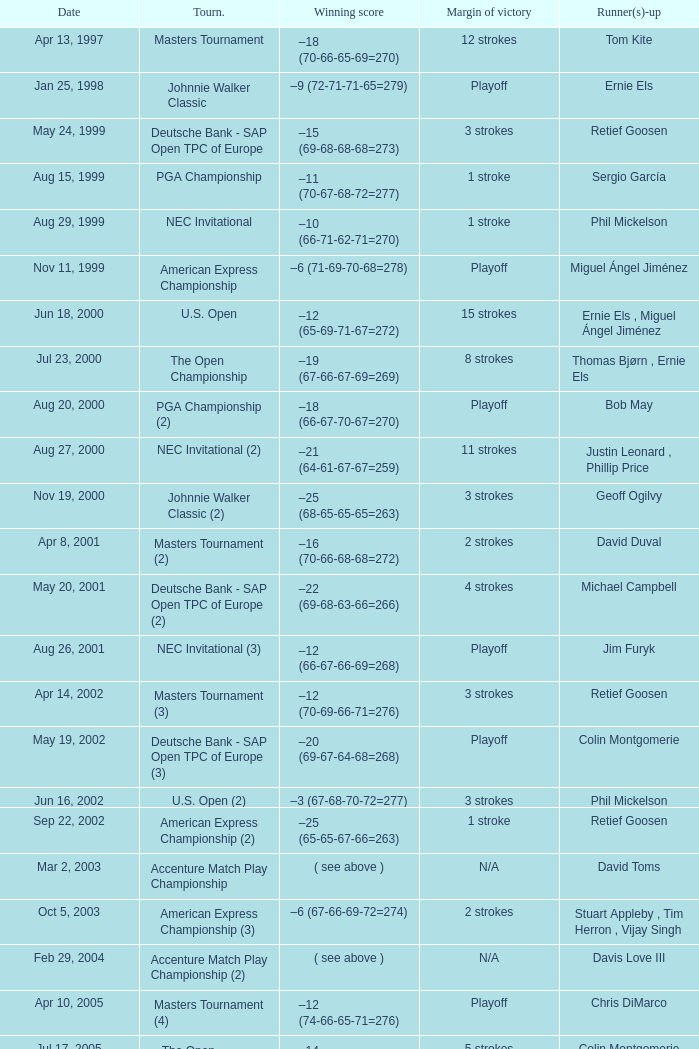Which Tournament has a Margin of victory of 7 strokes Bridgestone Invitational (8). 